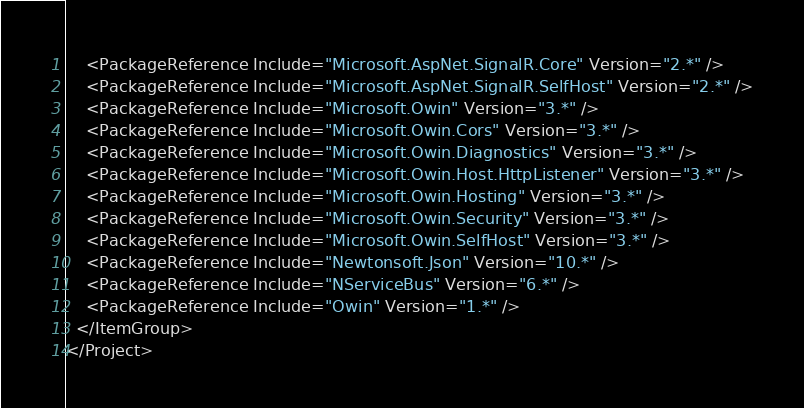<code> <loc_0><loc_0><loc_500><loc_500><_XML_>    <PackageReference Include="Microsoft.AspNet.SignalR.Core" Version="2.*" />
    <PackageReference Include="Microsoft.AspNet.SignalR.SelfHost" Version="2.*" />
    <PackageReference Include="Microsoft.Owin" Version="3.*" />
    <PackageReference Include="Microsoft.Owin.Cors" Version="3.*" />
    <PackageReference Include="Microsoft.Owin.Diagnostics" Version="3.*" />
    <PackageReference Include="Microsoft.Owin.Host.HttpListener" Version="3.*" />
    <PackageReference Include="Microsoft.Owin.Hosting" Version="3.*" />
    <PackageReference Include="Microsoft.Owin.Security" Version="3.*" />
    <PackageReference Include="Microsoft.Owin.SelfHost" Version="3.*" />
    <PackageReference Include="Newtonsoft.Json" Version="10.*" />
    <PackageReference Include="NServiceBus" Version="6.*" />
    <PackageReference Include="Owin" Version="1.*" />
  </ItemGroup>
</Project></code> 